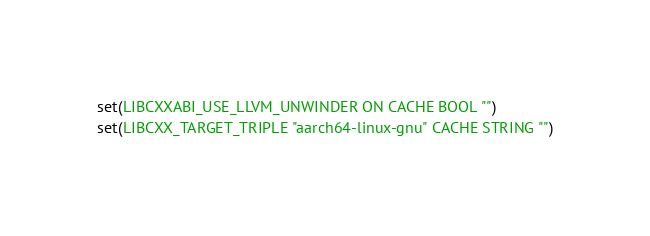<code> <loc_0><loc_0><loc_500><loc_500><_CMake_>set(LIBCXXABI_USE_LLVM_UNWINDER ON CACHE BOOL "")
set(LIBCXX_TARGET_TRIPLE "aarch64-linux-gnu" CACHE STRING "")
</code> 